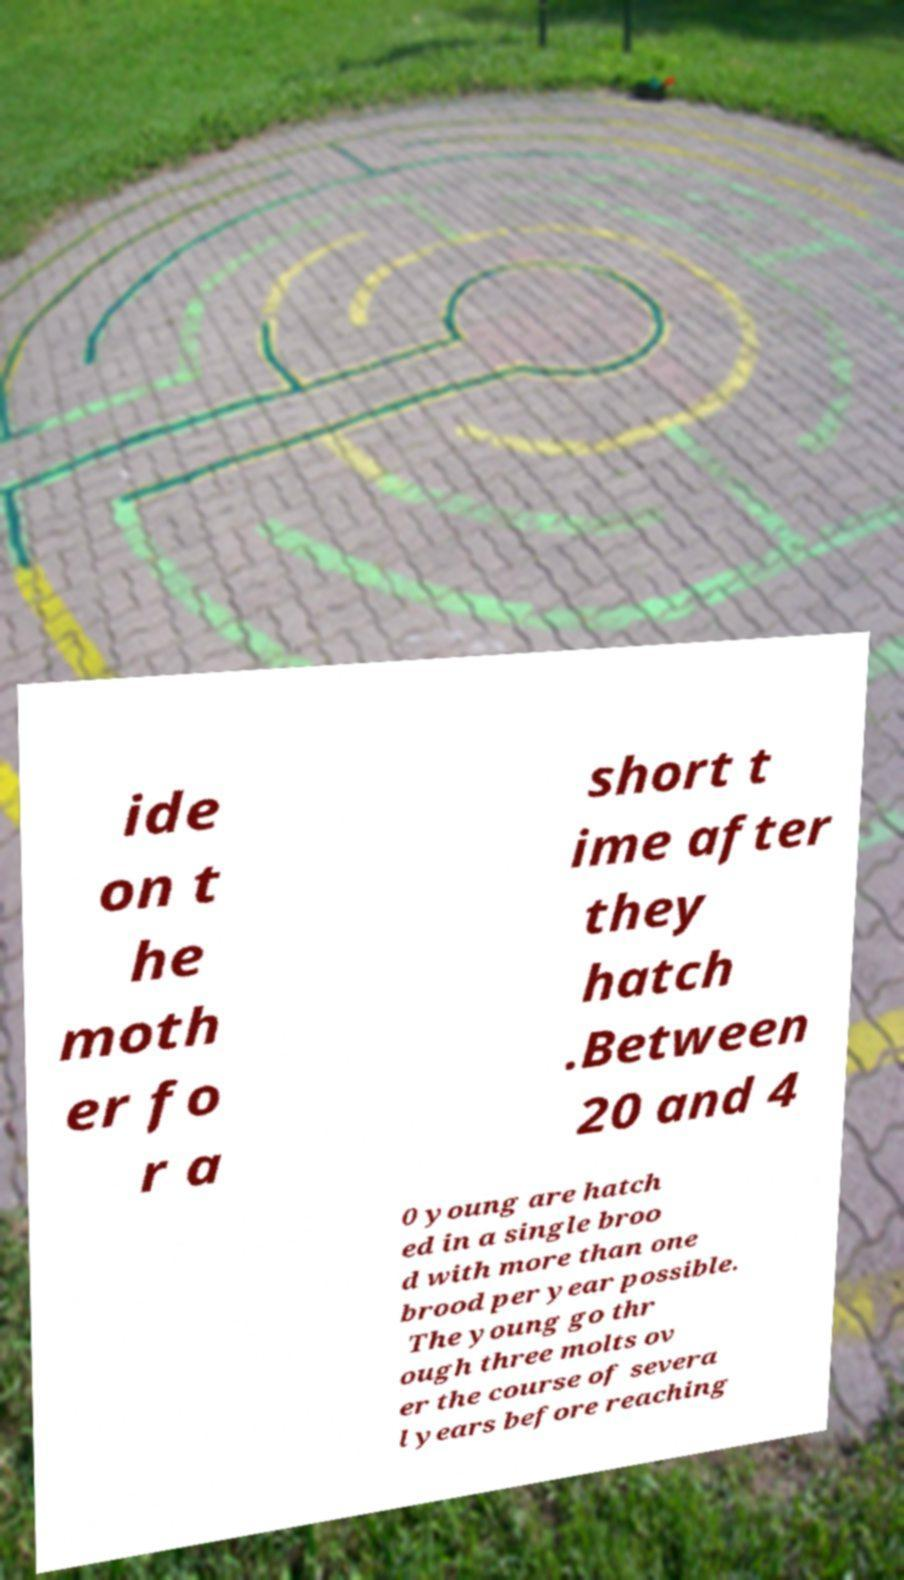Can you accurately transcribe the text from the provided image for me? ide on t he moth er fo r a short t ime after they hatch .Between 20 and 4 0 young are hatch ed in a single broo d with more than one brood per year possible. The young go thr ough three molts ov er the course of severa l years before reaching 